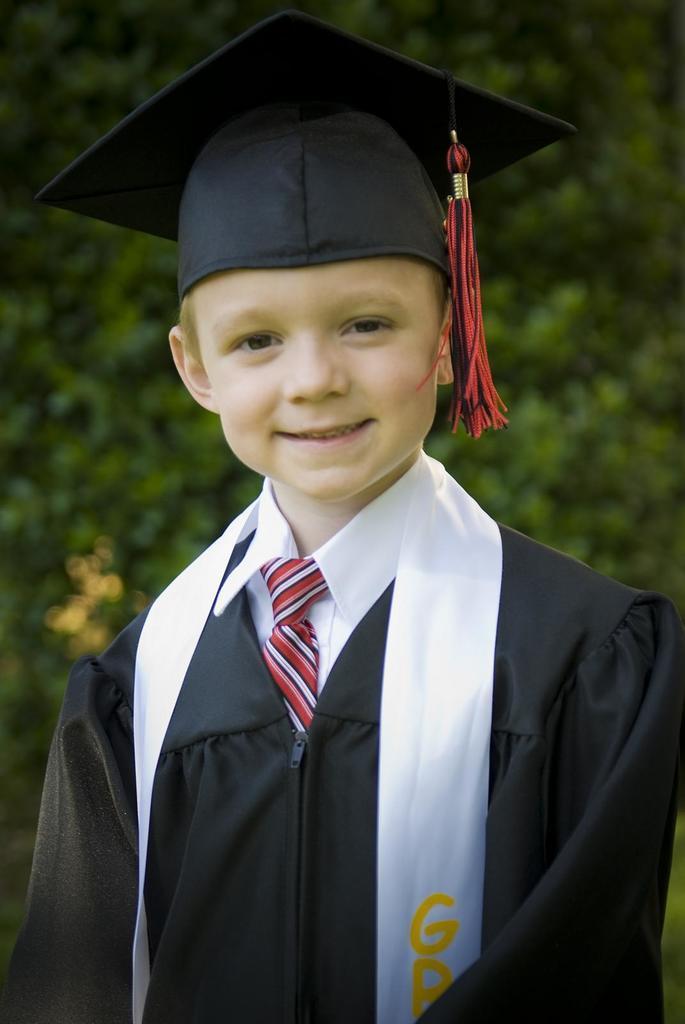Can you describe this image briefly? In this picture, we can see a person standing and we can see the background is blurred. 